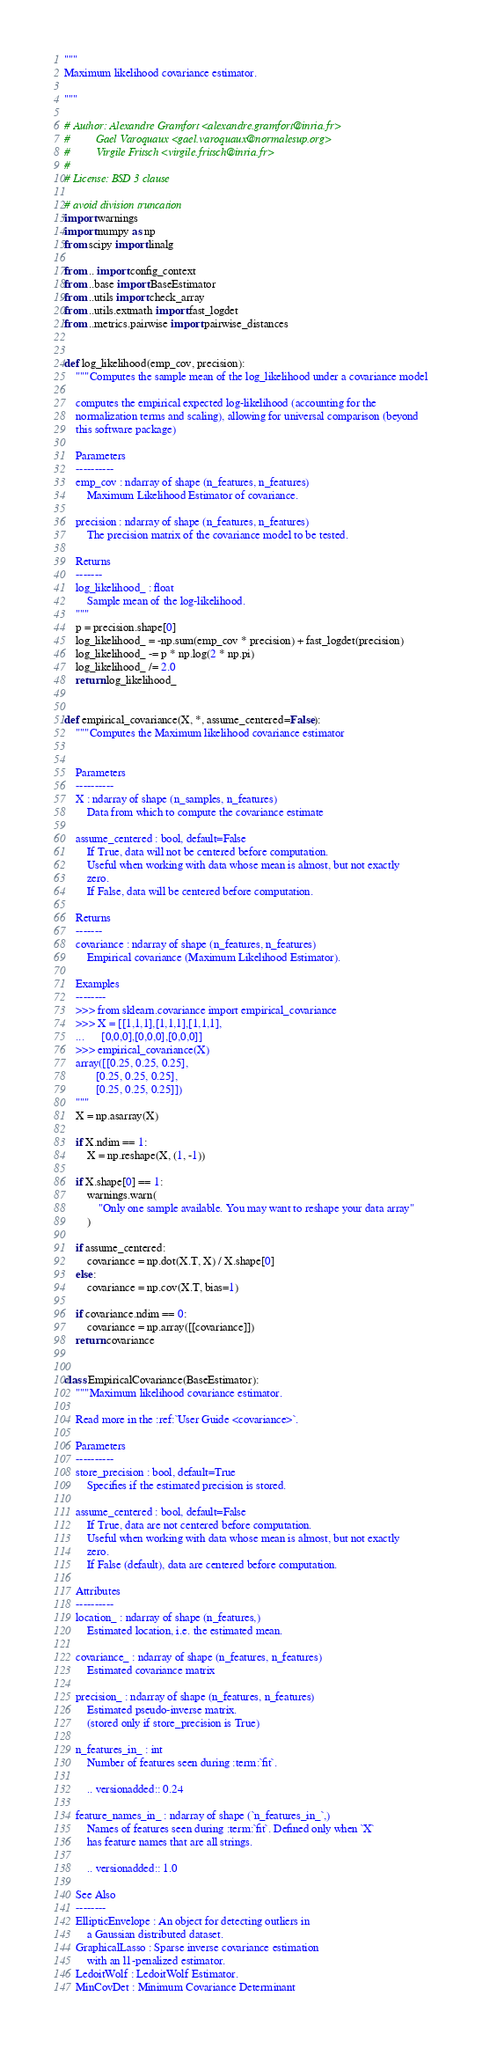<code> <loc_0><loc_0><loc_500><loc_500><_Python_>"""
Maximum likelihood covariance estimator.

"""

# Author: Alexandre Gramfort <alexandre.gramfort@inria.fr>
#         Gael Varoquaux <gael.varoquaux@normalesup.org>
#         Virgile Fritsch <virgile.fritsch@inria.fr>
#
# License: BSD 3 clause

# avoid division truncation
import warnings
import numpy as np
from scipy import linalg

from .. import config_context
from ..base import BaseEstimator
from ..utils import check_array
from ..utils.extmath import fast_logdet
from ..metrics.pairwise import pairwise_distances


def log_likelihood(emp_cov, precision):
    """Computes the sample mean of the log_likelihood under a covariance model

    computes the empirical expected log-likelihood (accounting for the
    normalization terms and scaling), allowing for universal comparison (beyond
    this software package)

    Parameters
    ----------
    emp_cov : ndarray of shape (n_features, n_features)
        Maximum Likelihood Estimator of covariance.

    precision : ndarray of shape (n_features, n_features)
        The precision matrix of the covariance model to be tested.

    Returns
    -------
    log_likelihood_ : float
        Sample mean of the log-likelihood.
    """
    p = precision.shape[0]
    log_likelihood_ = -np.sum(emp_cov * precision) + fast_logdet(precision)
    log_likelihood_ -= p * np.log(2 * np.pi)
    log_likelihood_ /= 2.0
    return log_likelihood_


def empirical_covariance(X, *, assume_centered=False):
    """Computes the Maximum likelihood covariance estimator


    Parameters
    ----------
    X : ndarray of shape (n_samples, n_features)
        Data from which to compute the covariance estimate

    assume_centered : bool, default=False
        If True, data will not be centered before computation.
        Useful when working with data whose mean is almost, but not exactly
        zero.
        If False, data will be centered before computation.

    Returns
    -------
    covariance : ndarray of shape (n_features, n_features)
        Empirical covariance (Maximum Likelihood Estimator).

    Examples
    --------
    >>> from sklearn.covariance import empirical_covariance
    >>> X = [[1,1,1],[1,1,1],[1,1,1],
    ...      [0,0,0],[0,0,0],[0,0,0]]
    >>> empirical_covariance(X)
    array([[0.25, 0.25, 0.25],
           [0.25, 0.25, 0.25],
           [0.25, 0.25, 0.25]])
    """
    X = np.asarray(X)

    if X.ndim == 1:
        X = np.reshape(X, (1, -1))

    if X.shape[0] == 1:
        warnings.warn(
            "Only one sample available. You may want to reshape your data array"
        )

    if assume_centered:
        covariance = np.dot(X.T, X) / X.shape[0]
    else:
        covariance = np.cov(X.T, bias=1)

    if covariance.ndim == 0:
        covariance = np.array([[covariance]])
    return covariance


class EmpiricalCovariance(BaseEstimator):
    """Maximum likelihood covariance estimator.

    Read more in the :ref:`User Guide <covariance>`.

    Parameters
    ----------
    store_precision : bool, default=True
        Specifies if the estimated precision is stored.

    assume_centered : bool, default=False
        If True, data are not centered before computation.
        Useful when working with data whose mean is almost, but not exactly
        zero.
        If False (default), data are centered before computation.

    Attributes
    ----------
    location_ : ndarray of shape (n_features,)
        Estimated location, i.e. the estimated mean.

    covariance_ : ndarray of shape (n_features, n_features)
        Estimated covariance matrix

    precision_ : ndarray of shape (n_features, n_features)
        Estimated pseudo-inverse matrix.
        (stored only if store_precision is True)

    n_features_in_ : int
        Number of features seen during :term:`fit`.

        .. versionadded:: 0.24

    feature_names_in_ : ndarray of shape (`n_features_in_`,)
        Names of features seen during :term:`fit`. Defined only when `X`
        has feature names that are all strings.

        .. versionadded:: 1.0

    See Also
    --------
    EllipticEnvelope : An object for detecting outliers in
        a Gaussian distributed dataset.
    GraphicalLasso : Sparse inverse covariance estimation
        with an l1-penalized estimator.
    LedoitWolf : LedoitWolf Estimator.
    MinCovDet : Minimum Covariance Determinant</code> 